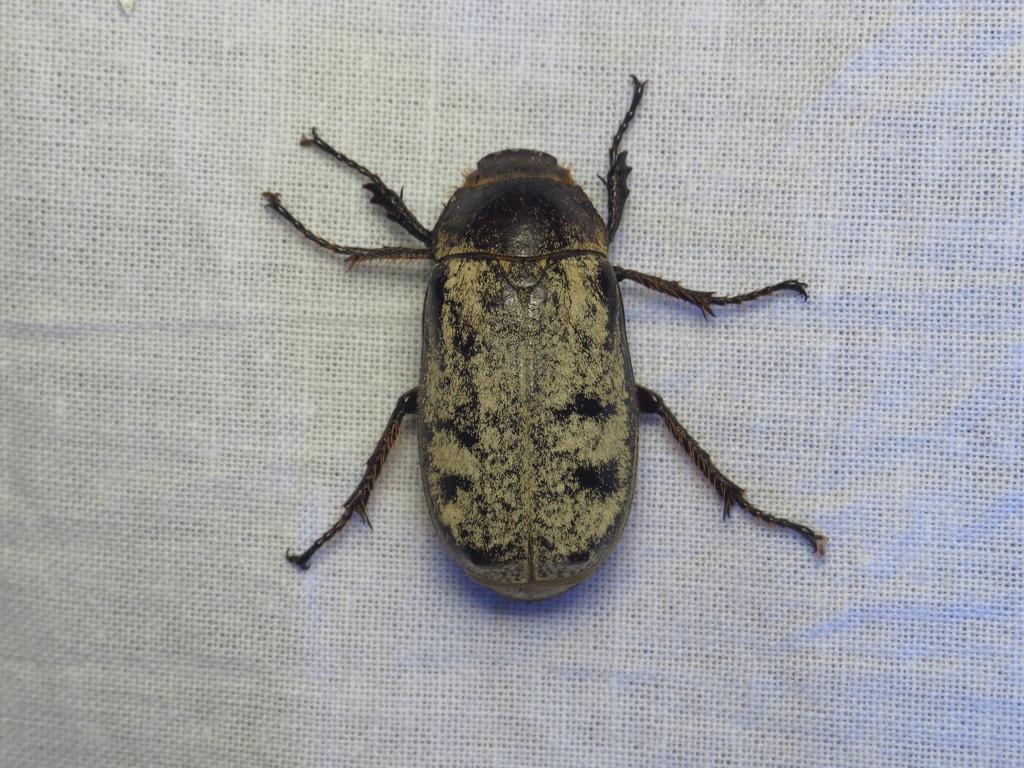How would you summarize this image in a sentence or two? In this image there is an insect which is on the white colour surface. 